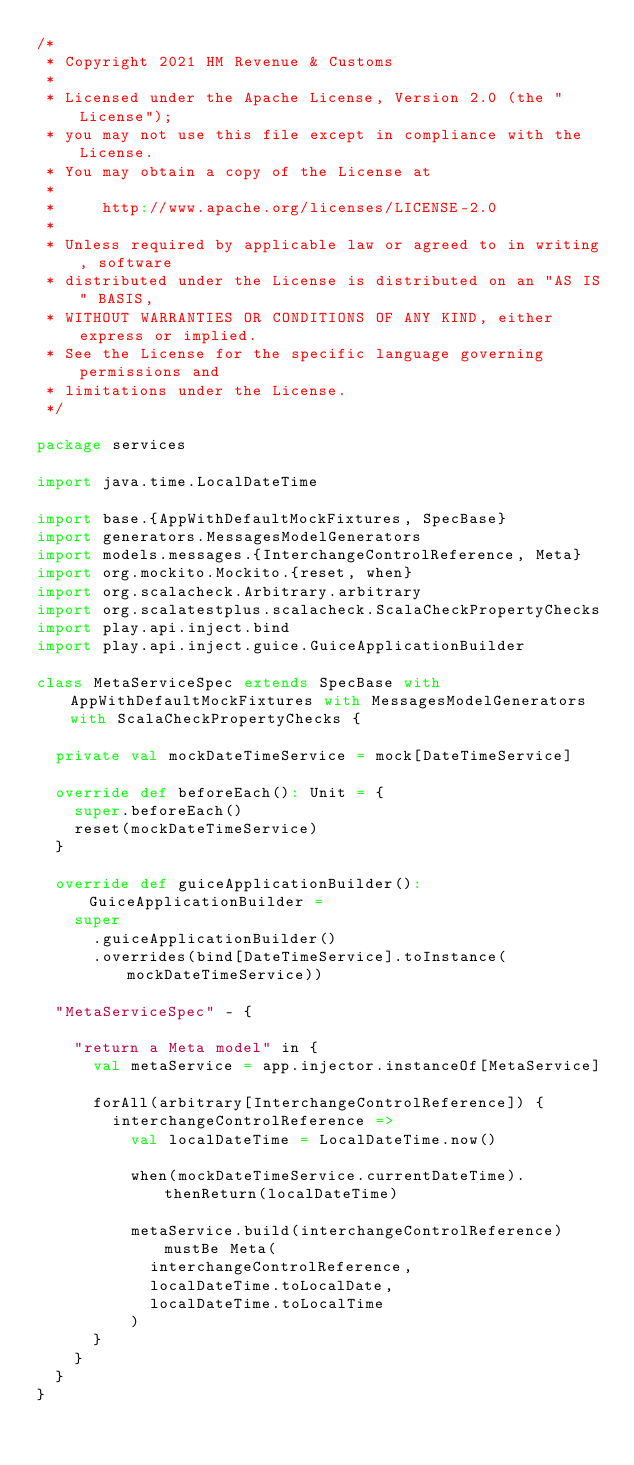Convert code to text. <code><loc_0><loc_0><loc_500><loc_500><_Scala_>/*
 * Copyright 2021 HM Revenue & Customs
 *
 * Licensed under the Apache License, Version 2.0 (the "License");
 * you may not use this file except in compliance with the License.
 * You may obtain a copy of the License at
 *
 *     http://www.apache.org/licenses/LICENSE-2.0
 *
 * Unless required by applicable law or agreed to in writing, software
 * distributed under the License is distributed on an "AS IS" BASIS,
 * WITHOUT WARRANTIES OR CONDITIONS OF ANY KIND, either express or implied.
 * See the License for the specific language governing permissions and
 * limitations under the License.
 */

package services

import java.time.LocalDateTime

import base.{AppWithDefaultMockFixtures, SpecBase}
import generators.MessagesModelGenerators
import models.messages.{InterchangeControlReference, Meta}
import org.mockito.Mockito.{reset, when}
import org.scalacheck.Arbitrary.arbitrary
import org.scalatestplus.scalacheck.ScalaCheckPropertyChecks
import play.api.inject.bind
import play.api.inject.guice.GuiceApplicationBuilder

class MetaServiceSpec extends SpecBase with AppWithDefaultMockFixtures with MessagesModelGenerators with ScalaCheckPropertyChecks {

  private val mockDateTimeService = mock[DateTimeService]

  override def beforeEach(): Unit = {
    super.beforeEach()
    reset(mockDateTimeService)
  }

  override def guiceApplicationBuilder(): GuiceApplicationBuilder =
    super
      .guiceApplicationBuilder()
      .overrides(bind[DateTimeService].toInstance(mockDateTimeService))

  "MetaServiceSpec" - {

    "return a Meta model" in {
      val metaService = app.injector.instanceOf[MetaService]

      forAll(arbitrary[InterchangeControlReference]) {
        interchangeControlReference =>
          val localDateTime = LocalDateTime.now()

          when(mockDateTimeService.currentDateTime).thenReturn(localDateTime)

          metaService.build(interchangeControlReference) mustBe Meta(
            interchangeControlReference,
            localDateTime.toLocalDate,
            localDateTime.toLocalTime
          )
      }
    }
  }
}
</code> 